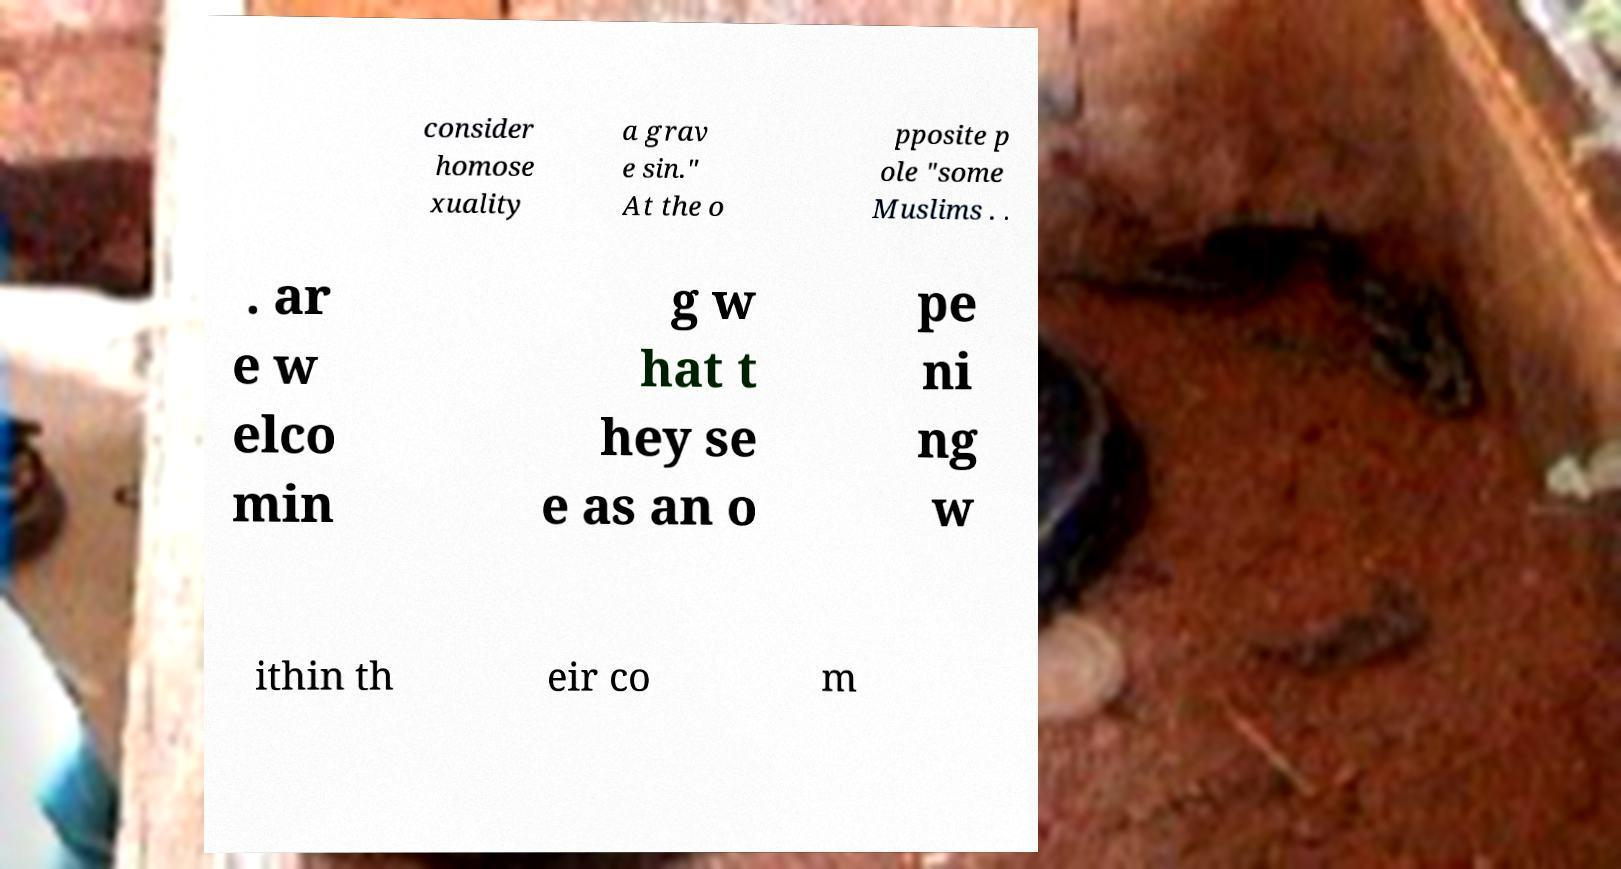Please identify and transcribe the text found in this image. consider homose xuality a grav e sin." At the o pposite p ole "some Muslims . . . ar e w elco min g w hat t hey se e as an o pe ni ng w ithin th eir co m 